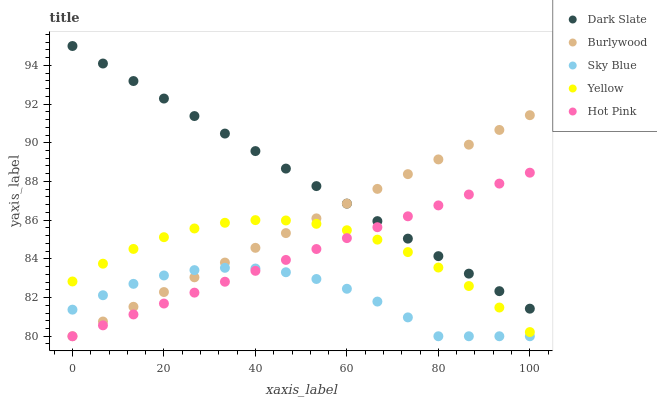Does Sky Blue have the minimum area under the curve?
Answer yes or no. Yes. Does Dark Slate have the maximum area under the curve?
Answer yes or no. Yes. Does Hot Pink have the minimum area under the curve?
Answer yes or no. No. Does Hot Pink have the maximum area under the curve?
Answer yes or no. No. Is Burlywood the smoothest?
Answer yes or no. Yes. Is Sky Blue the roughest?
Answer yes or no. Yes. Is Dark Slate the smoothest?
Answer yes or no. No. Is Dark Slate the roughest?
Answer yes or no. No. Does Burlywood have the lowest value?
Answer yes or no. Yes. Does Dark Slate have the lowest value?
Answer yes or no. No. Does Dark Slate have the highest value?
Answer yes or no. Yes. Does Hot Pink have the highest value?
Answer yes or no. No. Is Sky Blue less than Dark Slate?
Answer yes or no. Yes. Is Dark Slate greater than Yellow?
Answer yes or no. Yes. Does Hot Pink intersect Sky Blue?
Answer yes or no. Yes. Is Hot Pink less than Sky Blue?
Answer yes or no. No. Is Hot Pink greater than Sky Blue?
Answer yes or no. No. Does Sky Blue intersect Dark Slate?
Answer yes or no. No. 